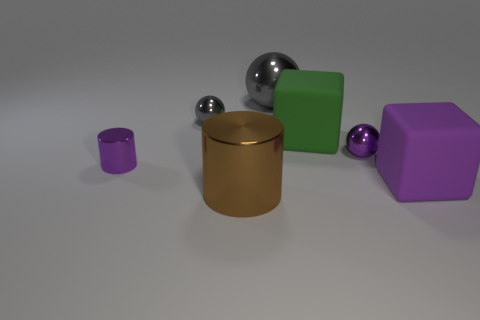Subtract all small balls. How many balls are left? 1 Add 1 purple metal cylinders. How many objects exist? 8 Subtract all cylinders. How many objects are left? 5 Add 3 small objects. How many small objects are left? 6 Add 7 tiny brown rubber blocks. How many tiny brown rubber blocks exist? 7 Subtract 0 green cylinders. How many objects are left? 7 Subtract all large brown things. Subtract all tiny blue rubber blocks. How many objects are left? 6 